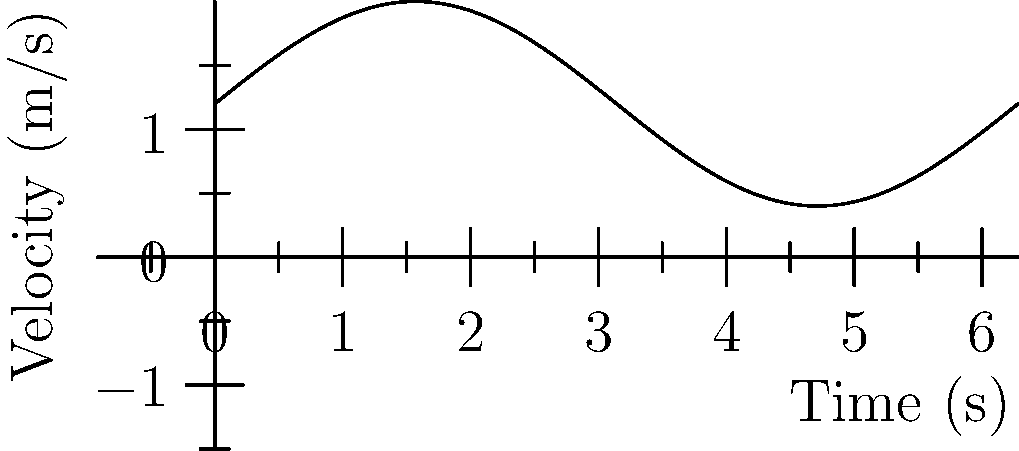A patient undergoes a walking test where their velocity is recorded over time, as shown in the graph. If the test lasts for 10 seconds, what is the total distance covered by the patient? To solve this problem, we need to follow these steps:

1. Recognize that the distance covered is the area under the velocity-time curve.

2. The velocity function appears to be sinusoidal, oscillating around a mean velocity. We can approximate it as:

   $v(t) = 1.2 + 0.8 \sin(t)$ m/s

3. To find the distance, we need to integrate this function over the time interval [0, 10]:

   $d = \int_0^{10} v(t) dt = \int_0^{10} (1.2 + 0.8 \sin(t)) dt$

4. Integrate the function:
   
   $d = [1.2t - 0.8 \cos(t)]_0^{10}$

5. Evaluate the integral:
   
   $d = (12 - 0.8 \cos(10)) - (0 - 0.8 \cos(0))$
   
   $d = 12 - 0.8 \cos(10) + 0.8$
   
   $d = 12.8 - 0.8 \cos(10)$

6. Calculate the final result:
   
   $d \approx 12.8 - 0.8 * (-0.8391) \approx 13.47$ m

Therefore, the patient covered approximately 13.47 meters during the 10-second walking test.
Answer: 13.47 m 